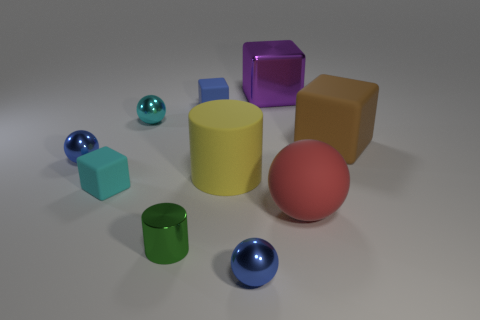Are there fewer large yellow cylinders in front of the large yellow matte cylinder than small blocks?
Your answer should be very brief. Yes. There is a tiny matte object behind the tiny cyan block; does it have the same shape as the tiny matte object on the left side of the green metal object?
Give a very brief answer. Yes. How many things are either blocks to the right of the big red sphere or big cubes?
Your answer should be very brief. 2. Is there a large block that is to the right of the big cube behind the matte block that is right of the purple shiny object?
Offer a terse response. Yes. Are there fewer small cylinders that are on the left side of the big yellow cylinder than matte blocks that are left of the purple block?
Ensure brevity in your answer.  Yes. There is another tiny cube that is the same material as the blue block; what color is it?
Ensure brevity in your answer.  Cyan. There is a small metal ball that is behind the blue metallic ball that is to the left of the small cyan matte cube; what is its color?
Your response must be concise. Cyan. There is a brown rubber thing that is the same size as the purple block; what shape is it?
Provide a short and direct response. Cube. What number of small balls are behind the big thing on the left side of the purple metal cube?
Provide a succinct answer. 2. Does the large matte cylinder have the same color as the small metallic cylinder?
Offer a terse response. No. 